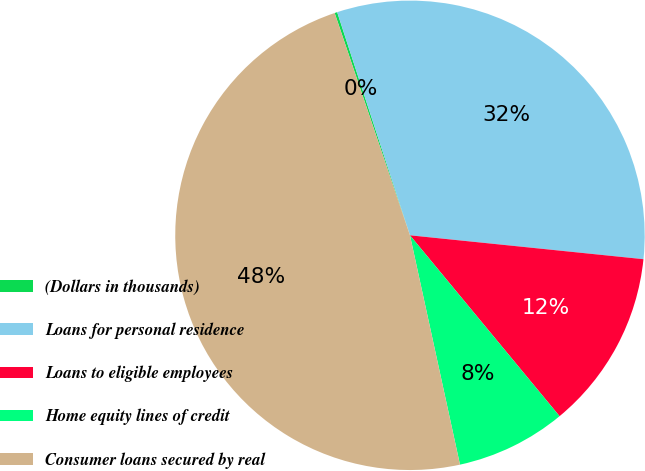<chart> <loc_0><loc_0><loc_500><loc_500><pie_chart><fcel>(Dollars in thousands)<fcel>Loans for personal residence<fcel>Loans to eligible employees<fcel>Home equity lines of credit<fcel>Consumer loans secured by real<nl><fcel>0.18%<fcel>31.64%<fcel>12.38%<fcel>7.58%<fcel>48.22%<nl></chart> 